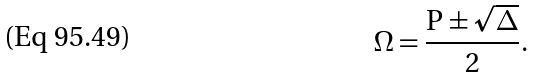<formula> <loc_0><loc_0><loc_500><loc_500>\Omega = \frac { { \mathrm P } \pm \sqrt { \Delta } } { 2 } .</formula> 